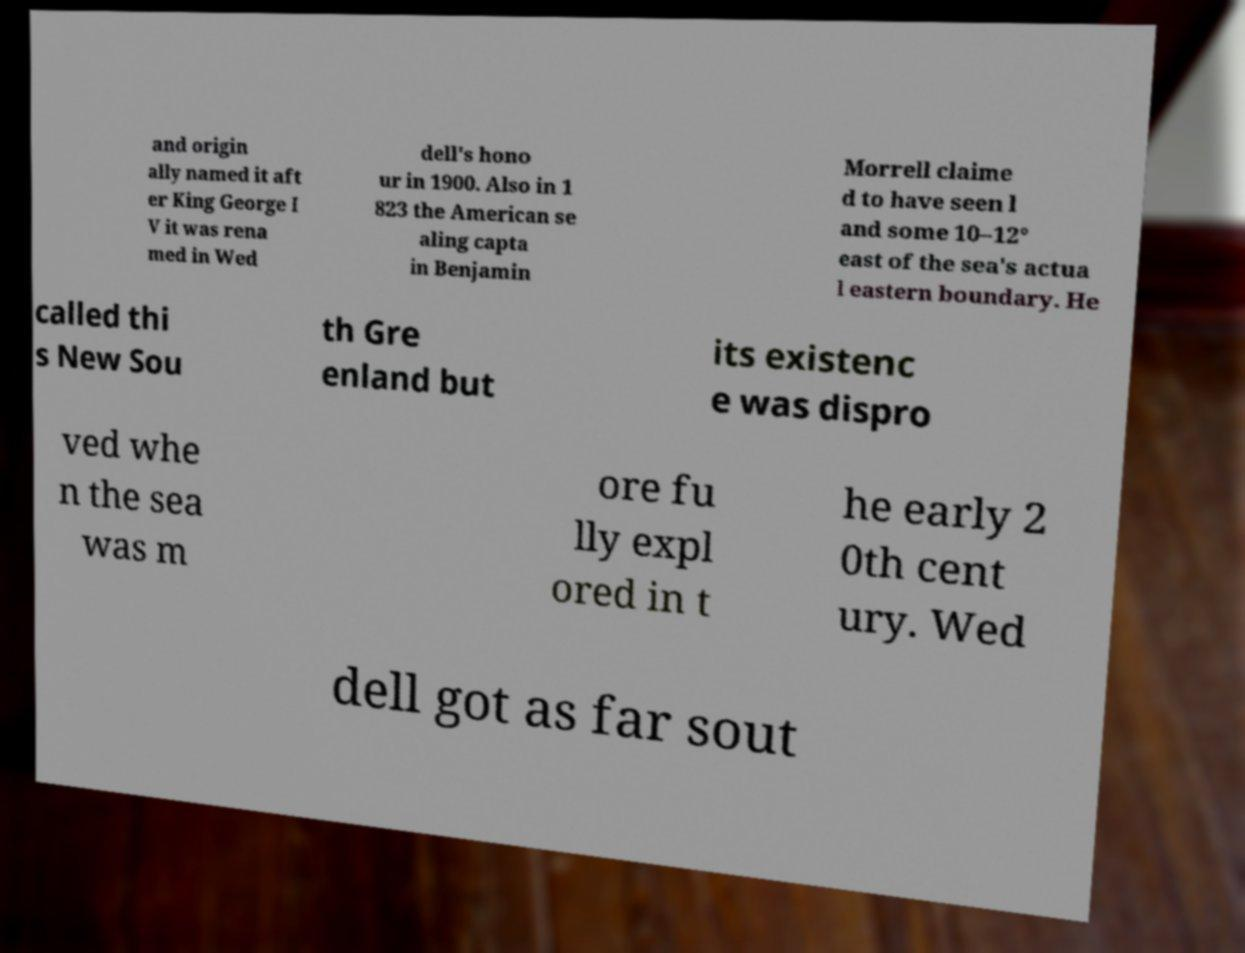Could you assist in decoding the text presented in this image and type it out clearly? and origin ally named it aft er King George I V it was rena med in Wed dell's hono ur in 1900. Also in 1 823 the American se aling capta in Benjamin Morrell claime d to have seen l and some 10–12° east of the sea's actua l eastern boundary. He called thi s New Sou th Gre enland but its existenc e was dispro ved whe n the sea was m ore fu lly expl ored in t he early 2 0th cent ury. Wed dell got as far sout 